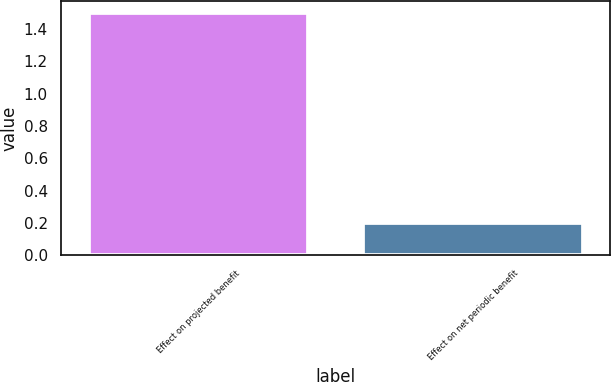<chart> <loc_0><loc_0><loc_500><loc_500><bar_chart><fcel>Effect on projected benefit<fcel>Effect on net periodic benefit<nl><fcel>1.5<fcel>0.2<nl></chart> 